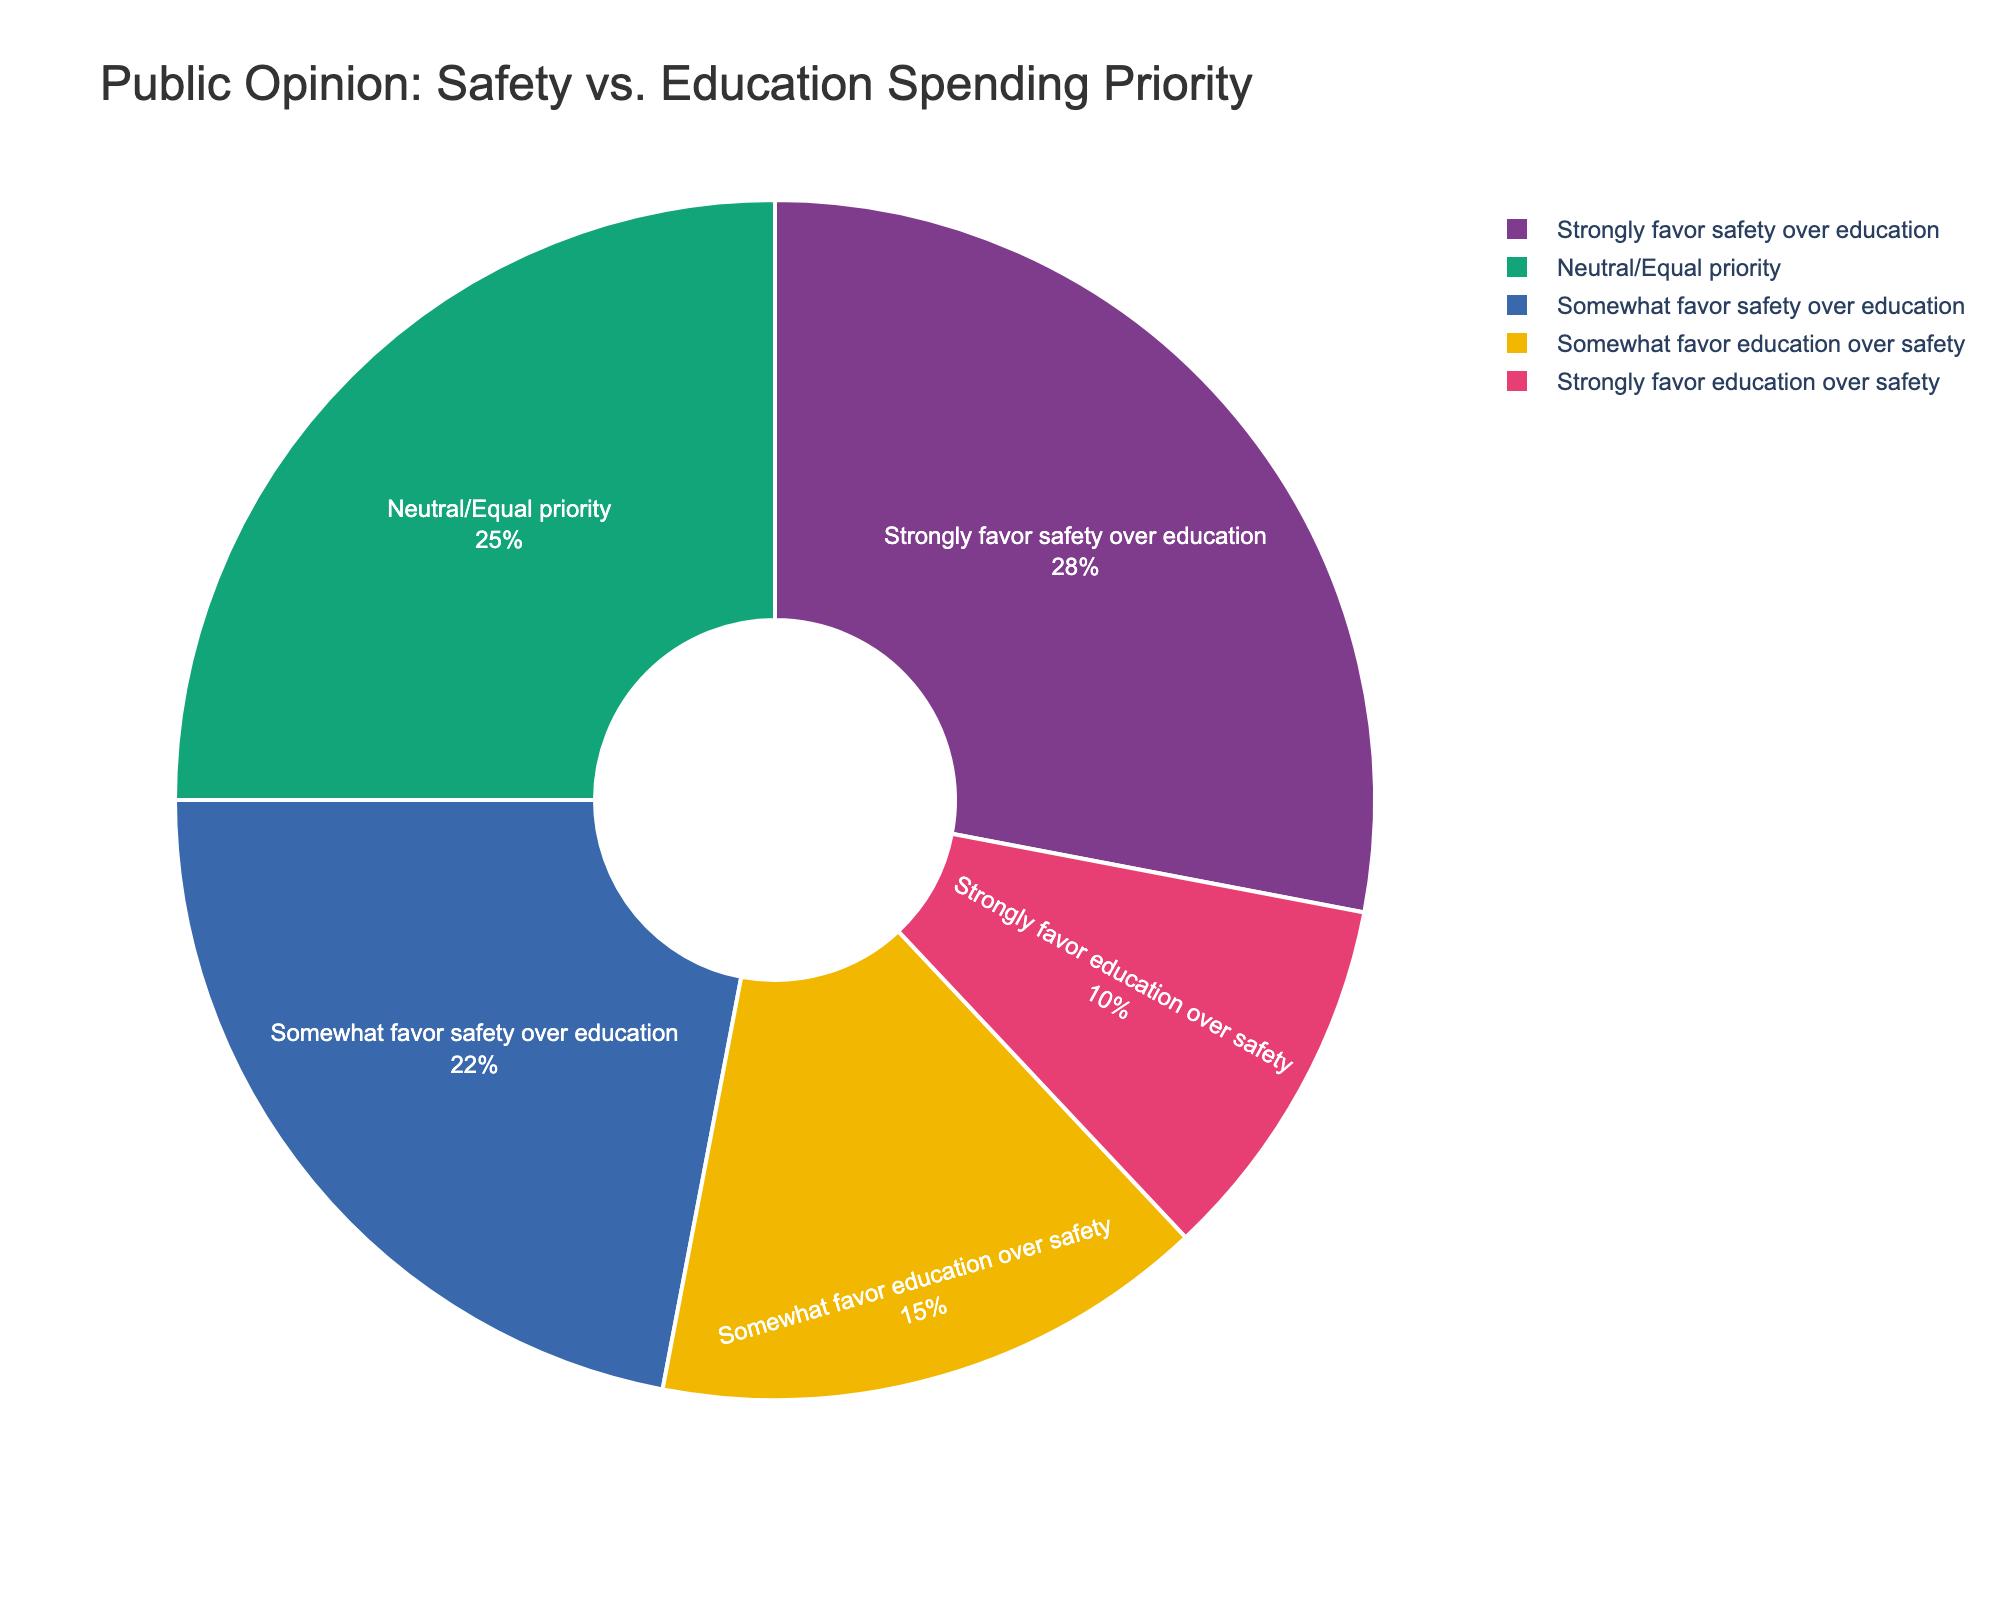What category has the highest percentage? The slice labeled "Strongly favor safety over education" is visually the largest in the pie chart, indicating it has the highest percentage.
Answer: Strongly favor safety over education What is the combined percentage of people who somewhat or strongly favor safety over education? Add the percentages of "Strongly favor safety over education" (28%) and "Somewhat favor safety over education" (22%). The combined percentage is 28 + 22 = 50%.
Answer: 50% Which category has the smallest percentage? The slice labeled "Strongly favor education over safety" is the smallest in the pie chart.
Answer: Strongly favor education over safety Is the percentage of people who are neutral/equal in priority higher than those who somewhat favor education over safety? Compare the slice sizes or percentage labels for "Neutral/Equal priority" (25%) and "Somewhat favor education over safety" (15%). Since 25% is greater than 15%, the neutral category is higher.
Answer: Yes What is the difference in percentage points between those who strongly favor safety and those who strongly favor education? Subtract the percentage of "Strongly favor education over safety" (10%) from "Strongly favor safety over education" (28%). The difference is 28 - 10 = 18 percentage points.
Answer: 18 percentage points What percentage of people either somewhat or strongly favor education over safety? Add the percentages of "Somewhat favor education over safety" (15%) and "Strongly favor education over safety" (10%). The combined percentage is 15 + 10 = 25%.
Answer: 25% Which two categories together approximately make up half of the pie chart? The sizes of "Strongly favor safety over education" (28%) and "Somewhat favor safety over education" (22%) together add up to 28 + 22 = 50%, which is approximately half of the pie chart.
Answer: Strongly favor safety over education and Somewhat favor safety over education Are there more people who have a neutral/equal priority than those who favor safety to any extent? The percentage for "Neutral/Equal priority" is 25%. The total percentage for those who favor safety to any extent is 50%, combining "Strongly favor safety over education" and "Somewhat favor safety over education". 25% is less than 50%, so there are fewer neutral people compared to those favoring safety.
Answer: No List the categories in descending order of their percentages. Start with the largest slice: "Strongly favor safety over education" (28%), followed by "Somewhat favor safety over education" (22%), "Neutral/Equal priority" (25%), "Somewhat favor education over safety" (15%), and finally "Strongly favor education over safety" (10%).
Answer: Strongly favor safety over education, Neutral/Equal priority, Somewhat favor safety over education, Somewhat favor education over safety, Strongly favor education over safety 